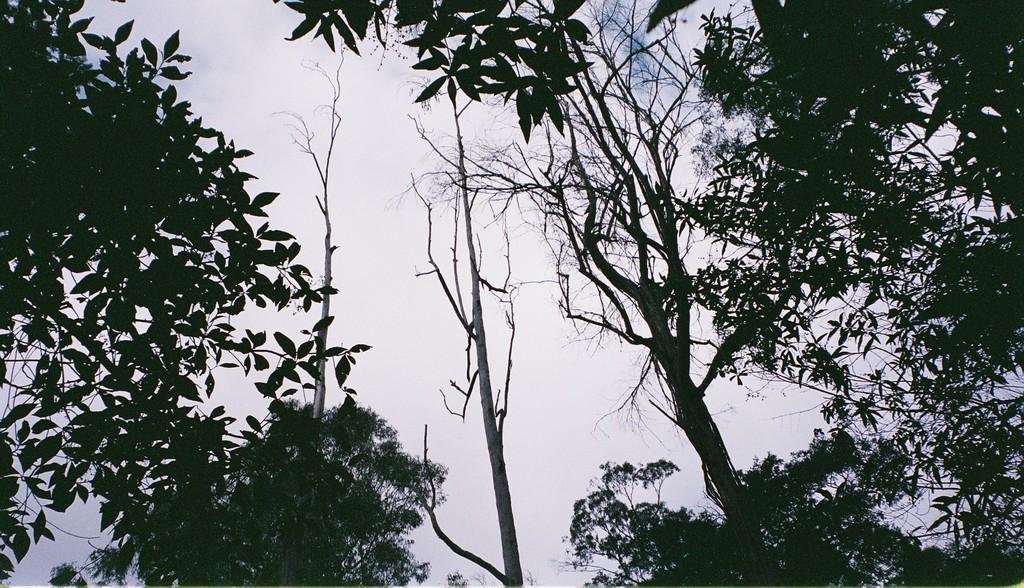In one or two sentences, can you explain what this image depicts? There are trees. In the background, there are clouds in the sky. 